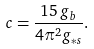Convert formula to latex. <formula><loc_0><loc_0><loc_500><loc_500>c = \frac { 1 5 \, g _ { b } } { 4 \pi ^ { 2 } g _ { \ast s } } .</formula> 